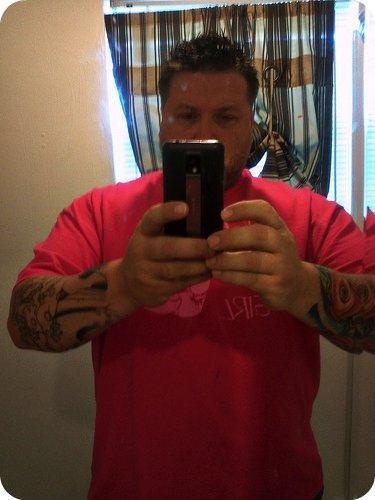How many stripes does the cow have?
Give a very brief answer. 0. 